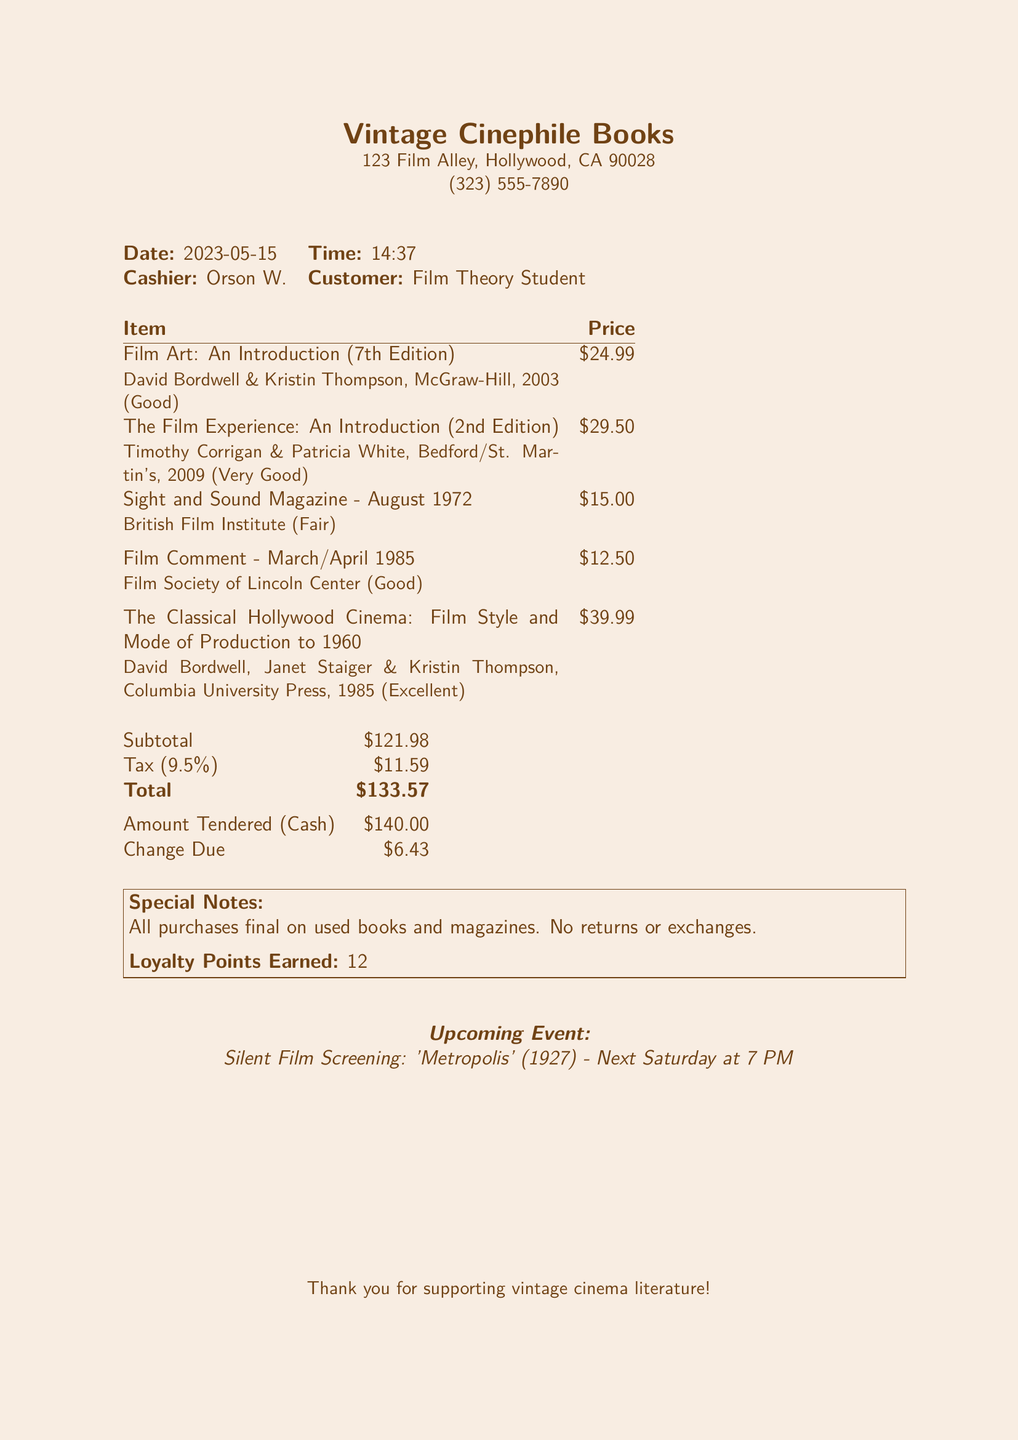What is the name of the bookstore? The bookstore is identified by the name "Vintage Cinephile Books" in the document.
Answer: Vintage Cinephile Books What is the condition of "Film Art: An Introduction (7th Edition)"? The document specifies that "Film Art: An Introduction (7th Edition)" is in "Good" condition.
Answer: Good Who is the cashier? The cashier's name is provided as "Orson W." in the document.
Answer: Orson W What is the total amount paid? The total amount is listed as $133.57 in the transaction document.
Answer: $133.57 What loyalty points were earned? The document states that 12 loyalty points were earned during this transaction.
Answer: 12 What is the date of this transaction? The transaction date is indicated as "2023-05-15" in the document.
Answer: 2023-05-15 What is the price of "The Classical Hollywood Cinema"? The price for "The Classical Hollywood Cinema: Film Style and Mode of Production to 1960" is mentioned as $39.99.
Answer: $39.99 What is the tax rate applied? The tax rate for this transaction is noted as 9.5% within the document.
Answer: 9.5% What event is upcoming at the bookstore? The document details an upcoming event, which is a screening of "Metropolis" on Saturday at 7 PM.
Answer: Silent Film Screening: 'Metropolis' (1927) - Next Saturday at 7 PM 